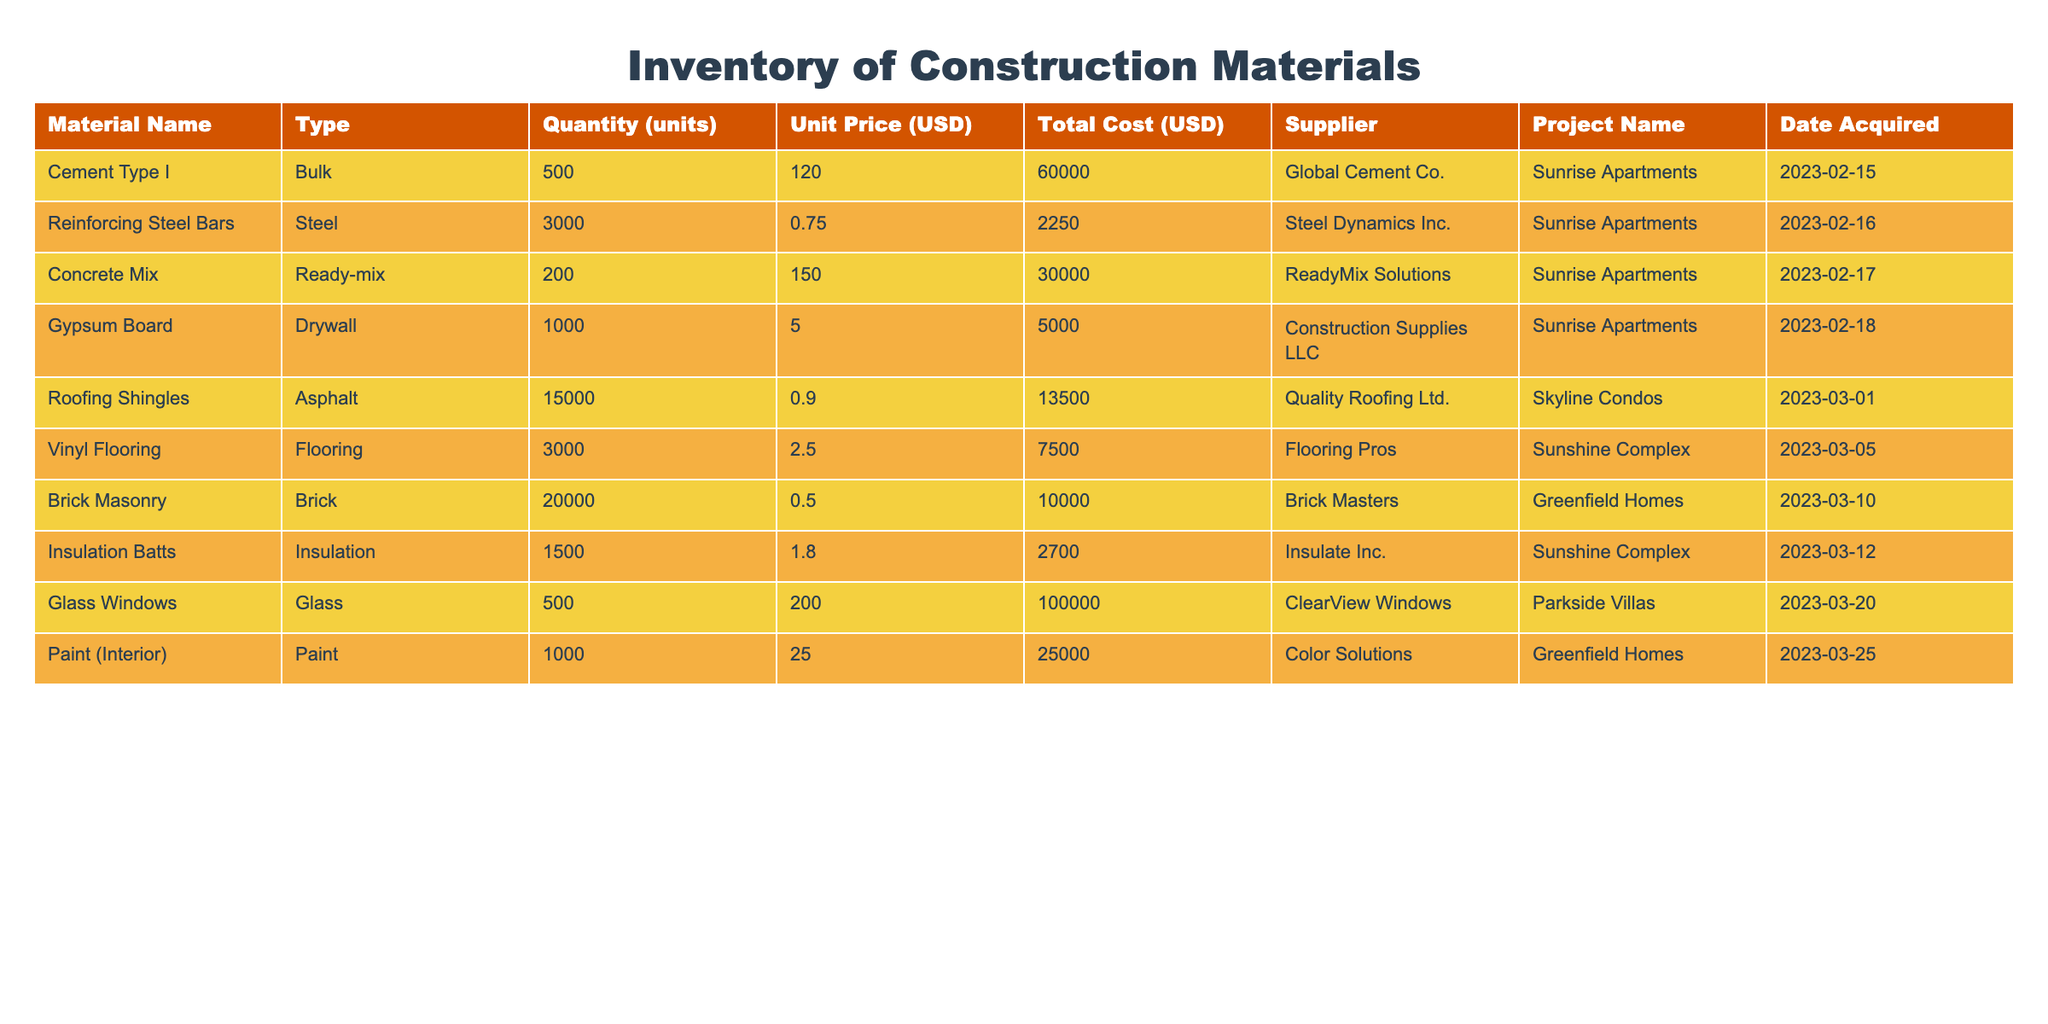What is the total cost of Cement Type I? In the table, the total cost is listed directly under the Total Cost column for Cement Type I. The value is 60000 USD.
Answer: 60000 USD How many units of Gypsum Board were acquired? The table shows that for Gypsum Board, the Quantity (units) is 1000.
Answer: 1000 Which supplier provided the Brick Masonry? By looking at the Supplier column in the table for Brick Masonry, we see that it was supplied by Brick Masters.
Answer: Brick Masters What is the total cost of all materials used in the Sunshine Complex project? To find the total cost for the Sunshine Complex, sum the Total Cost for materials associated with that project: Vinyl Flooring (7500) + Insulation Batts (2700) = 10200 USD.
Answer: 10200 USD Are Roofing Shingles supplied by Quality Roofing Ltd.? The table lists Quality Roofing Ltd. as the supplier for Roofing Shingles, confirming that the statement is true.
Answer: Yes What is the average unit price of materials used in the Sunrise Apartments project? The unit prices for the materials in the Sunrise Apartments are 120, 0.75, 150, 5, leading to an average calculated by summing these and dividing by the count: (120 + 0.75 + 150 + 5) / 4 = 43.4375.
Answer: 43.44 How much does the total cost of Glass Windows exceed the total cost of Vinyl Flooring? The total cost of Glass Windows is 100000, and Vinyl Flooring is 7500. The difference is calculated as 100000 - 7500 = 92500.
Answer: 92500 Which material had the largest unit price and what is that price? Scanning through the unit price column, Glass Windows has the largest unit price at 200 USD per unit.
Answer: 200 USD Did any material cost less than 5 USD per unit? By examining the unit price column, we see that Reinforcing Steel Bars (0.75), Brick Masonry (0.50), and Insulation Batts (1.80) all cost less than 5 USD per unit, confirming that materials do fit this criterion.
Answer: Yes 